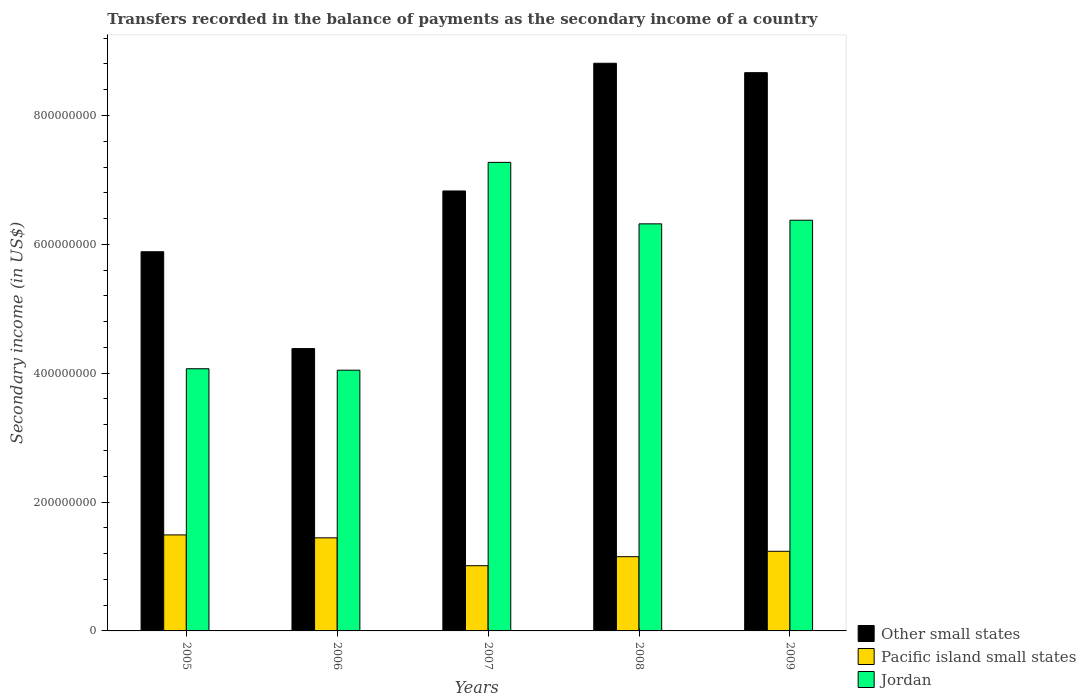How many different coloured bars are there?
Give a very brief answer. 3. Are the number of bars per tick equal to the number of legend labels?
Your answer should be compact. Yes. In how many cases, is the number of bars for a given year not equal to the number of legend labels?
Provide a succinct answer. 0. What is the secondary income of in Jordan in 2009?
Your answer should be compact. 6.37e+08. Across all years, what is the maximum secondary income of in Pacific island small states?
Offer a terse response. 1.49e+08. Across all years, what is the minimum secondary income of in Other small states?
Your answer should be compact. 4.38e+08. What is the total secondary income of in Jordan in the graph?
Offer a terse response. 2.81e+09. What is the difference between the secondary income of in Jordan in 2005 and that in 2007?
Offer a very short reply. -3.20e+08. What is the difference between the secondary income of in Pacific island small states in 2007 and the secondary income of in Jordan in 2005?
Your response must be concise. -3.06e+08. What is the average secondary income of in Pacific island small states per year?
Your answer should be very brief. 1.27e+08. In the year 2008, what is the difference between the secondary income of in Jordan and secondary income of in Other small states?
Your answer should be compact. -2.49e+08. What is the ratio of the secondary income of in Jordan in 2005 to that in 2009?
Offer a terse response. 0.64. Is the secondary income of in Jordan in 2005 less than that in 2009?
Offer a very short reply. Yes. Is the difference between the secondary income of in Jordan in 2006 and 2009 greater than the difference between the secondary income of in Other small states in 2006 and 2009?
Your response must be concise. Yes. What is the difference between the highest and the second highest secondary income of in Other small states?
Offer a terse response. 1.46e+07. What is the difference between the highest and the lowest secondary income of in Pacific island small states?
Provide a succinct answer. 4.78e+07. What does the 3rd bar from the left in 2007 represents?
Offer a terse response. Jordan. What does the 1st bar from the right in 2007 represents?
Your answer should be very brief. Jordan. How many years are there in the graph?
Your answer should be compact. 5. What is the difference between two consecutive major ticks on the Y-axis?
Your response must be concise. 2.00e+08. Are the values on the major ticks of Y-axis written in scientific E-notation?
Keep it short and to the point. No. How many legend labels are there?
Give a very brief answer. 3. How are the legend labels stacked?
Provide a short and direct response. Vertical. What is the title of the graph?
Ensure brevity in your answer.  Transfers recorded in the balance of payments as the secondary income of a country. What is the label or title of the X-axis?
Provide a succinct answer. Years. What is the label or title of the Y-axis?
Keep it short and to the point. Secondary income (in US$). What is the Secondary income (in US$) in Other small states in 2005?
Give a very brief answer. 5.89e+08. What is the Secondary income (in US$) in Pacific island small states in 2005?
Keep it short and to the point. 1.49e+08. What is the Secondary income (in US$) in Jordan in 2005?
Ensure brevity in your answer.  4.07e+08. What is the Secondary income (in US$) in Other small states in 2006?
Make the answer very short. 4.38e+08. What is the Secondary income (in US$) of Pacific island small states in 2006?
Your answer should be very brief. 1.44e+08. What is the Secondary income (in US$) of Jordan in 2006?
Keep it short and to the point. 4.05e+08. What is the Secondary income (in US$) of Other small states in 2007?
Your response must be concise. 6.83e+08. What is the Secondary income (in US$) of Pacific island small states in 2007?
Your answer should be compact. 1.01e+08. What is the Secondary income (in US$) in Jordan in 2007?
Give a very brief answer. 7.27e+08. What is the Secondary income (in US$) of Other small states in 2008?
Provide a short and direct response. 8.81e+08. What is the Secondary income (in US$) in Pacific island small states in 2008?
Your response must be concise. 1.15e+08. What is the Secondary income (in US$) of Jordan in 2008?
Provide a succinct answer. 6.32e+08. What is the Secondary income (in US$) of Other small states in 2009?
Give a very brief answer. 8.66e+08. What is the Secondary income (in US$) of Pacific island small states in 2009?
Provide a succinct answer. 1.24e+08. What is the Secondary income (in US$) of Jordan in 2009?
Your answer should be compact. 6.37e+08. Across all years, what is the maximum Secondary income (in US$) of Other small states?
Provide a succinct answer. 8.81e+08. Across all years, what is the maximum Secondary income (in US$) of Pacific island small states?
Provide a short and direct response. 1.49e+08. Across all years, what is the maximum Secondary income (in US$) in Jordan?
Offer a very short reply. 7.27e+08. Across all years, what is the minimum Secondary income (in US$) in Other small states?
Offer a very short reply. 4.38e+08. Across all years, what is the minimum Secondary income (in US$) of Pacific island small states?
Make the answer very short. 1.01e+08. Across all years, what is the minimum Secondary income (in US$) in Jordan?
Offer a very short reply. 4.05e+08. What is the total Secondary income (in US$) in Other small states in the graph?
Provide a short and direct response. 3.46e+09. What is the total Secondary income (in US$) in Pacific island small states in the graph?
Provide a succinct answer. 6.33e+08. What is the total Secondary income (in US$) in Jordan in the graph?
Your response must be concise. 2.81e+09. What is the difference between the Secondary income (in US$) of Other small states in 2005 and that in 2006?
Keep it short and to the point. 1.50e+08. What is the difference between the Secondary income (in US$) of Pacific island small states in 2005 and that in 2006?
Your response must be concise. 4.54e+06. What is the difference between the Secondary income (in US$) in Jordan in 2005 and that in 2006?
Ensure brevity in your answer.  2.26e+06. What is the difference between the Secondary income (in US$) of Other small states in 2005 and that in 2007?
Ensure brevity in your answer.  -9.43e+07. What is the difference between the Secondary income (in US$) of Pacific island small states in 2005 and that in 2007?
Make the answer very short. 4.78e+07. What is the difference between the Secondary income (in US$) of Jordan in 2005 and that in 2007?
Make the answer very short. -3.20e+08. What is the difference between the Secondary income (in US$) of Other small states in 2005 and that in 2008?
Keep it short and to the point. -2.93e+08. What is the difference between the Secondary income (in US$) in Pacific island small states in 2005 and that in 2008?
Give a very brief answer. 3.38e+07. What is the difference between the Secondary income (in US$) in Jordan in 2005 and that in 2008?
Give a very brief answer. -2.25e+08. What is the difference between the Secondary income (in US$) of Other small states in 2005 and that in 2009?
Provide a short and direct response. -2.78e+08. What is the difference between the Secondary income (in US$) in Pacific island small states in 2005 and that in 2009?
Your answer should be compact. 2.54e+07. What is the difference between the Secondary income (in US$) in Jordan in 2005 and that in 2009?
Keep it short and to the point. -2.31e+08. What is the difference between the Secondary income (in US$) of Other small states in 2006 and that in 2007?
Offer a terse response. -2.45e+08. What is the difference between the Secondary income (in US$) of Pacific island small states in 2006 and that in 2007?
Make the answer very short. 4.33e+07. What is the difference between the Secondary income (in US$) in Jordan in 2006 and that in 2007?
Your answer should be compact. -3.23e+08. What is the difference between the Secondary income (in US$) of Other small states in 2006 and that in 2008?
Your answer should be compact. -4.43e+08. What is the difference between the Secondary income (in US$) of Pacific island small states in 2006 and that in 2008?
Offer a very short reply. 2.93e+07. What is the difference between the Secondary income (in US$) of Jordan in 2006 and that in 2008?
Your answer should be very brief. -2.27e+08. What is the difference between the Secondary income (in US$) in Other small states in 2006 and that in 2009?
Offer a terse response. -4.28e+08. What is the difference between the Secondary income (in US$) of Pacific island small states in 2006 and that in 2009?
Ensure brevity in your answer.  2.09e+07. What is the difference between the Secondary income (in US$) in Jordan in 2006 and that in 2009?
Give a very brief answer. -2.33e+08. What is the difference between the Secondary income (in US$) in Other small states in 2007 and that in 2008?
Your response must be concise. -1.98e+08. What is the difference between the Secondary income (in US$) in Pacific island small states in 2007 and that in 2008?
Provide a short and direct response. -1.40e+07. What is the difference between the Secondary income (in US$) of Jordan in 2007 and that in 2008?
Your answer should be compact. 9.54e+07. What is the difference between the Secondary income (in US$) of Other small states in 2007 and that in 2009?
Keep it short and to the point. -1.84e+08. What is the difference between the Secondary income (in US$) in Pacific island small states in 2007 and that in 2009?
Provide a short and direct response. -2.24e+07. What is the difference between the Secondary income (in US$) in Jordan in 2007 and that in 2009?
Provide a short and direct response. 8.98e+07. What is the difference between the Secondary income (in US$) in Other small states in 2008 and that in 2009?
Give a very brief answer. 1.46e+07. What is the difference between the Secondary income (in US$) of Pacific island small states in 2008 and that in 2009?
Your response must be concise. -8.40e+06. What is the difference between the Secondary income (in US$) of Jordan in 2008 and that in 2009?
Keep it short and to the point. -5.65e+06. What is the difference between the Secondary income (in US$) in Other small states in 2005 and the Secondary income (in US$) in Pacific island small states in 2006?
Your response must be concise. 4.44e+08. What is the difference between the Secondary income (in US$) of Other small states in 2005 and the Secondary income (in US$) of Jordan in 2006?
Your answer should be compact. 1.84e+08. What is the difference between the Secondary income (in US$) of Pacific island small states in 2005 and the Secondary income (in US$) of Jordan in 2006?
Keep it short and to the point. -2.56e+08. What is the difference between the Secondary income (in US$) in Other small states in 2005 and the Secondary income (in US$) in Pacific island small states in 2007?
Ensure brevity in your answer.  4.87e+08. What is the difference between the Secondary income (in US$) of Other small states in 2005 and the Secondary income (in US$) of Jordan in 2007?
Offer a very short reply. -1.39e+08. What is the difference between the Secondary income (in US$) in Pacific island small states in 2005 and the Secondary income (in US$) in Jordan in 2007?
Offer a terse response. -5.78e+08. What is the difference between the Secondary income (in US$) of Other small states in 2005 and the Secondary income (in US$) of Pacific island small states in 2008?
Your answer should be very brief. 4.73e+08. What is the difference between the Secondary income (in US$) in Other small states in 2005 and the Secondary income (in US$) in Jordan in 2008?
Provide a short and direct response. -4.33e+07. What is the difference between the Secondary income (in US$) in Pacific island small states in 2005 and the Secondary income (in US$) in Jordan in 2008?
Offer a terse response. -4.83e+08. What is the difference between the Secondary income (in US$) of Other small states in 2005 and the Secondary income (in US$) of Pacific island small states in 2009?
Ensure brevity in your answer.  4.65e+08. What is the difference between the Secondary income (in US$) of Other small states in 2005 and the Secondary income (in US$) of Jordan in 2009?
Provide a short and direct response. -4.90e+07. What is the difference between the Secondary income (in US$) of Pacific island small states in 2005 and the Secondary income (in US$) of Jordan in 2009?
Your answer should be very brief. -4.88e+08. What is the difference between the Secondary income (in US$) in Other small states in 2006 and the Secondary income (in US$) in Pacific island small states in 2007?
Your response must be concise. 3.37e+08. What is the difference between the Secondary income (in US$) in Other small states in 2006 and the Secondary income (in US$) in Jordan in 2007?
Provide a succinct answer. -2.89e+08. What is the difference between the Secondary income (in US$) of Pacific island small states in 2006 and the Secondary income (in US$) of Jordan in 2007?
Provide a succinct answer. -5.83e+08. What is the difference between the Secondary income (in US$) in Other small states in 2006 and the Secondary income (in US$) in Pacific island small states in 2008?
Offer a terse response. 3.23e+08. What is the difference between the Secondary income (in US$) of Other small states in 2006 and the Secondary income (in US$) of Jordan in 2008?
Provide a short and direct response. -1.94e+08. What is the difference between the Secondary income (in US$) in Pacific island small states in 2006 and the Secondary income (in US$) in Jordan in 2008?
Ensure brevity in your answer.  -4.87e+08. What is the difference between the Secondary income (in US$) of Other small states in 2006 and the Secondary income (in US$) of Pacific island small states in 2009?
Offer a terse response. 3.15e+08. What is the difference between the Secondary income (in US$) in Other small states in 2006 and the Secondary income (in US$) in Jordan in 2009?
Your response must be concise. -1.99e+08. What is the difference between the Secondary income (in US$) in Pacific island small states in 2006 and the Secondary income (in US$) in Jordan in 2009?
Your answer should be very brief. -4.93e+08. What is the difference between the Secondary income (in US$) in Other small states in 2007 and the Secondary income (in US$) in Pacific island small states in 2008?
Make the answer very short. 5.68e+08. What is the difference between the Secondary income (in US$) in Other small states in 2007 and the Secondary income (in US$) in Jordan in 2008?
Keep it short and to the point. 5.10e+07. What is the difference between the Secondary income (in US$) of Pacific island small states in 2007 and the Secondary income (in US$) of Jordan in 2008?
Ensure brevity in your answer.  -5.31e+08. What is the difference between the Secondary income (in US$) of Other small states in 2007 and the Secondary income (in US$) of Pacific island small states in 2009?
Make the answer very short. 5.59e+08. What is the difference between the Secondary income (in US$) of Other small states in 2007 and the Secondary income (in US$) of Jordan in 2009?
Offer a very short reply. 4.54e+07. What is the difference between the Secondary income (in US$) in Pacific island small states in 2007 and the Secondary income (in US$) in Jordan in 2009?
Keep it short and to the point. -5.36e+08. What is the difference between the Secondary income (in US$) in Other small states in 2008 and the Secondary income (in US$) in Pacific island small states in 2009?
Your answer should be very brief. 7.57e+08. What is the difference between the Secondary income (in US$) in Other small states in 2008 and the Secondary income (in US$) in Jordan in 2009?
Your answer should be very brief. 2.44e+08. What is the difference between the Secondary income (in US$) of Pacific island small states in 2008 and the Secondary income (in US$) of Jordan in 2009?
Offer a very short reply. -5.22e+08. What is the average Secondary income (in US$) in Other small states per year?
Your answer should be very brief. 6.91e+08. What is the average Secondary income (in US$) in Pacific island small states per year?
Your answer should be compact. 1.27e+08. What is the average Secondary income (in US$) in Jordan per year?
Offer a very short reply. 5.62e+08. In the year 2005, what is the difference between the Secondary income (in US$) in Other small states and Secondary income (in US$) in Pacific island small states?
Your answer should be very brief. 4.40e+08. In the year 2005, what is the difference between the Secondary income (in US$) in Other small states and Secondary income (in US$) in Jordan?
Keep it short and to the point. 1.82e+08. In the year 2005, what is the difference between the Secondary income (in US$) of Pacific island small states and Secondary income (in US$) of Jordan?
Offer a very short reply. -2.58e+08. In the year 2006, what is the difference between the Secondary income (in US$) in Other small states and Secondary income (in US$) in Pacific island small states?
Provide a short and direct response. 2.94e+08. In the year 2006, what is the difference between the Secondary income (in US$) of Other small states and Secondary income (in US$) of Jordan?
Offer a terse response. 3.36e+07. In the year 2006, what is the difference between the Secondary income (in US$) in Pacific island small states and Secondary income (in US$) in Jordan?
Make the answer very short. -2.60e+08. In the year 2007, what is the difference between the Secondary income (in US$) in Other small states and Secondary income (in US$) in Pacific island small states?
Offer a very short reply. 5.82e+08. In the year 2007, what is the difference between the Secondary income (in US$) in Other small states and Secondary income (in US$) in Jordan?
Keep it short and to the point. -4.44e+07. In the year 2007, what is the difference between the Secondary income (in US$) of Pacific island small states and Secondary income (in US$) of Jordan?
Ensure brevity in your answer.  -6.26e+08. In the year 2008, what is the difference between the Secondary income (in US$) of Other small states and Secondary income (in US$) of Pacific island small states?
Make the answer very short. 7.66e+08. In the year 2008, what is the difference between the Secondary income (in US$) in Other small states and Secondary income (in US$) in Jordan?
Your response must be concise. 2.49e+08. In the year 2008, what is the difference between the Secondary income (in US$) in Pacific island small states and Secondary income (in US$) in Jordan?
Make the answer very short. -5.17e+08. In the year 2009, what is the difference between the Secondary income (in US$) of Other small states and Secondary income (in US$) of Pacific island small states?
Keep it short and to the point. 7.43e+08. In the year 2009, what is the difference between the Secondary income (in US$) in Other small states and Secondary income (in US$) in Jordan?
Provide a short and direct response. 2.29e+08. In the year 2009, what is the difference between the Secondary income (in US$) of Pacific island small states and Secondary income (in US$) of Jordan?
Your answer should be compact. -5.14e+08. What is the ratio of the Secondary income (in US$) of Other small states in 2005 to that in 2006?
Provide a succinct answer. 1.34. What is the ratio of the Secondary income (in US$) of Pacific island small states in 2005 to that in 2006?
Provide a succinct answer. 1.03. What is the ratio of the Secondary income (in US$) in Jordan in 2005 to that in 2006?
Keep it short and to the point. 1.01. What is the ratio of the Secondary income (in US$) of Other small states in 2005 to that in 2007?
Your answer should be compact. 0.86. What is the ratio of the Secondary income (in US$) of Pacific island small states in 2005 to that in 2007?
Your answer should be compact. 1.47. What is the ratio of the Secondary income (in US$) of Jordan in 2005 to that in 2007?
Your answer should be very brief. 0.56. What is the ratio of the Secondary income (in US$) of Other small states in 2005 to that in 2008?
Offer a terse response. 0.67. What is the ratio of the Secondary income (in US$) of Pacific island small states in 2005 to that in 2008?
Make the answer very short. 1.29. What is the ratio of the Secondary income (in US$) in Jordan in 2005 to that in 2008?
Provide a succinct answer. 0.64. What is the ratio of the Secondary income (in US$) of Other small states in 2005 to that in 2009?
Your answer should be compact. 0.68. What is the ratio of the Secondary income (in US$) of Pacific island small states in 2005 to that in 2009?
Your answer should be very brief. 1.21. What is the ratio of the Secondary income (in US$) of Jordan in 2005 to that in 2009?
Keep it short and to the point. 0.64. What is the ratio of the Secondary income (in US$) in Other small states in 2006 to that in 2007?
Make the answer very short. 0.64. What is the ratio of the Secondary income (in US$) in Pacific island small states in 2006 to that in 2007?
Provide a succinct answer. 1.43. What is the ratio of the Secondary income (in US$) of Jordan in 2006 to that in 2007?
Provide a short and direct response. 0.56. What is the ratio of the Secondary income (in US$) in Other small states in 2006 to that in 2008?
Your response must be concise. 0.5. What is the ratio of the Secondary income (in US$) in Pacific island small states in 2006 to that in 2008?
Provide a succinct answer. 1.25. What is the ratio of the Secondary income (in US$) in Jordan in 2006 to that in 2008?
Your answer should be very brief. 0.64. What is the ratio of the Secondary income (in US$) in Other small states in 2006 to that in 2009?
Your response must be concise. 0.51. What is the ratio of the Secondary income (in US$) of Pacific island small states in 2006 to that in 2009?
Offer a terse response. 1.17. What is the ratio of the Secondary income (in US$) in Jordan in 2006 to that in 2009?
Give a very brief answer. 0.63. What is the ratio of the Secondary income (in US$) in Other small states in 2007 to that in 2008?
Your answer should be very brief. 0.78. What is the ratio of the Secondary income (in US$) of Pacific island small states in 2007 to that in 2008?
Make the answer very short. 0.88. What is the ratio of the Secondary income (in US$) in Jordan in 2007 to that in 2008?
Ensure brevity in your answer.  1.15. What is the ratio of the Secondary income (in US$) in Other small states in 2007 to that in 2009?
Your answer should be compact. 0.79. What is the ratio of the Secondary income (in US$) of Pacific island small states in 2007 to that in 2009?
Your response must be concise. 0.82. What is the ratio of the Secondary income (in US$) in Jordan in 2007 to that in 2009?
Make the answer very short. 1.14. What is the ratio of the Secondary income (in US$) in Other small states in 2008 to that in 2009?
Make the answer very short. 1.02. What is the ratio of the Secondary income (in US$) of Pacific island small states in 2008 to that in 2009?
Ensure brevity in your answer.  0.93. What is the ratio of the Secondary income (in US$) of Jordan in 2008 to that in 2009?
Offer a terse response. 0.99. What is the difference between the highest and the second highest Secondary income (in US$) in Other small states?
Keep it short and to the point. 1.46e+07. What is the difference between the highest and the second highest Secondary income (in US$) of Pacific island small states?
Make the answer very short. 4.54e+06. What is the difference between the highest and the second highest Secondary income (in US$) in Jordan?
Your answer should be compact. 8.98e+07. What is the difference between the highest and the lowest Secondary income (in US$) of Other small states?
Provide a short and direct response. 4.43e+08. What is the difference between the highest and the lowest Secondary income (in US$) in Pacific island small states?
Provide a short and direct response. 4.78e+07. What is the difference between the highest and the lowest Secondary income (in US$) in Jordan?
Provide a succinct answer. 3.23e+08. 